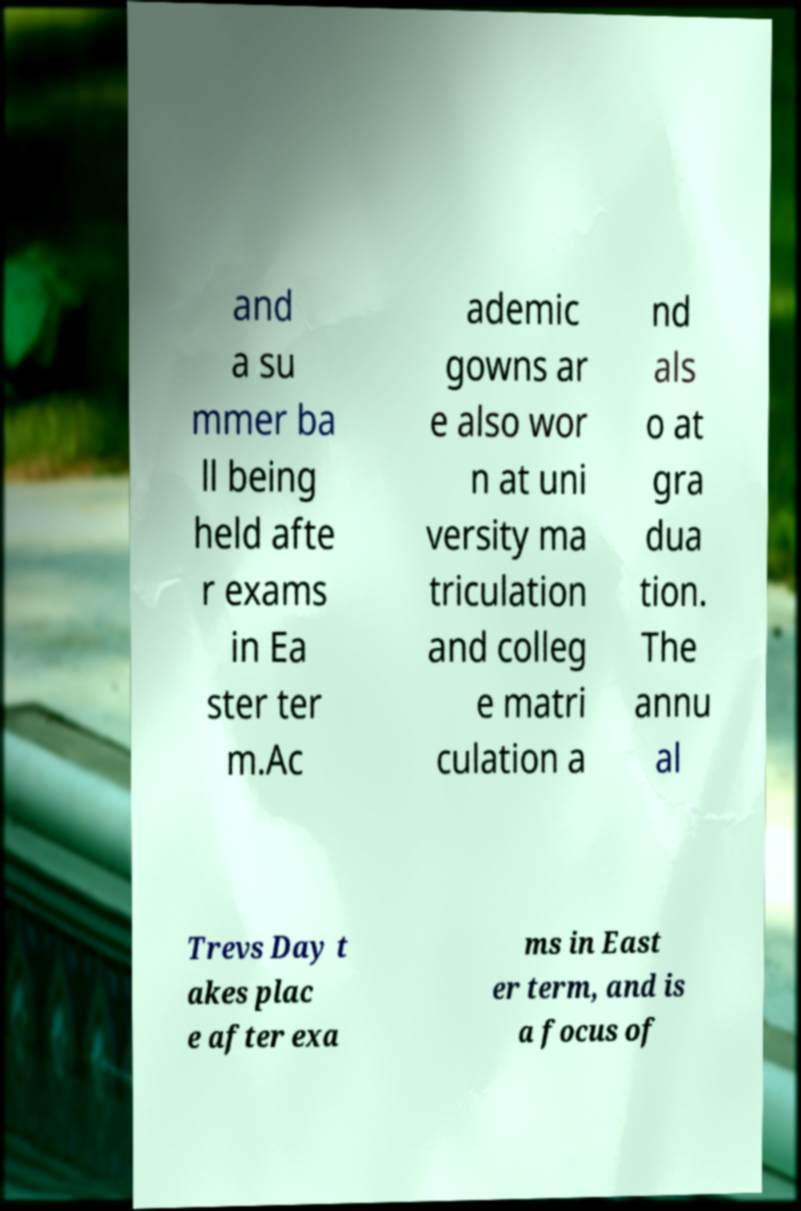Could you assist in decoding the text presented in this image and type it out clearly? and a su mmer ba ll being held afte r exams in Ea ster ter m.Ac ademic gowns ar e also wor n at uni versity ma triculation and colleg e matri culation a nd als o at gra dua tion. The annu al Trevs Day t akes plac e after exa ms in East er term, and is a focus of 